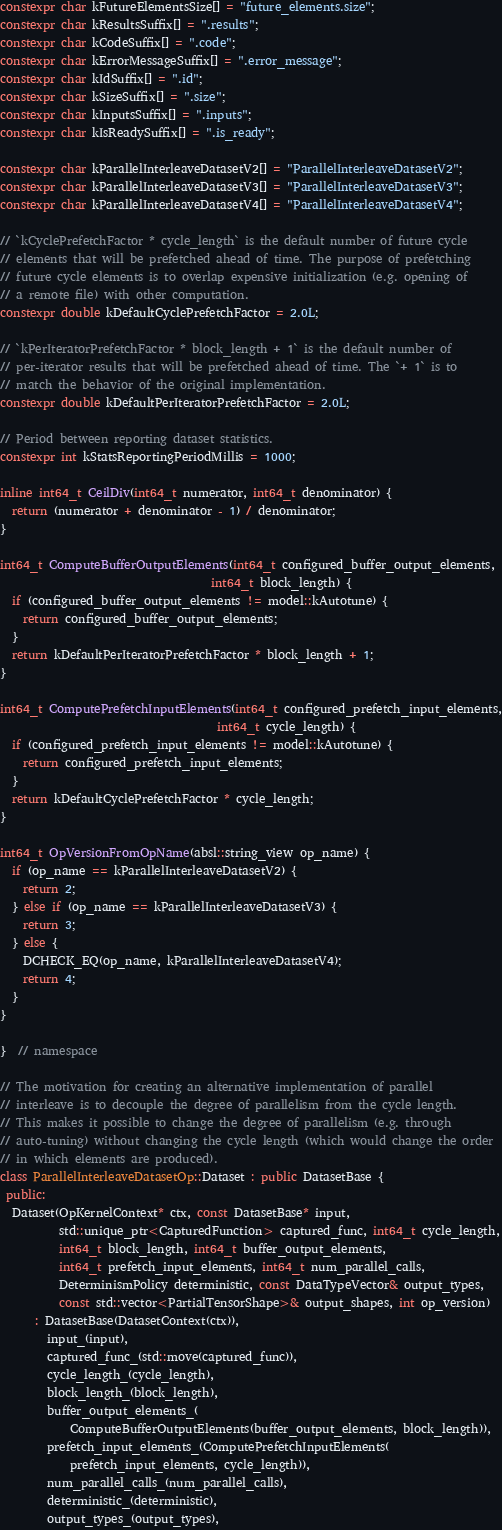<code> <loc_0><loc_0><loc_500><loc_500><_C++_>constexpr char kFutureElementsSize[] = "future_elements.size";
constexpr char kResultsSuffix[] = ".results";
constexpr char kCodeSuffix[] = ".code";
constexpr char kErrorMessageSuffix[] = ".error_message";
constexpr char kIdSuffix[] = ".id";
constexpr char kSizeSuffix[] = ".size";
constexpr char kInputsSuffix[] = ".inputs";
constexpr char kIsReadySuffix[] = ".is_ready";

constexpr char kParallelInterleaveDatasetV2[] = "ParallelInterleaveDatasetV2";
constexpr char kParallelInterleaveDatasetV3[] = "ParallelInterleaveDatasetV3";
constexpr char kParallelInterleaveDatasetV4[] = "ParallelInterleaveDatasetV4";

// `kCyclePrefetchFactor * cycle_length` is the default number of future cycle
// elements that will be prefetched ahead of time. The purpose of prefetching
// future cycle elements is to overlap expensive initialization (e.g. opening of
// a remote file) with other computation.
constexpr double kDefaultCyclePrefetchFactor = 2.0L;

// `kPerIteratorPrefetchFactor * block_length + 1` is the default number of
// per-iterator results that will be prefetched ahead of time. The `+ 1` is to
// match the behavior of the original implementation.
constexpr double kDefaultPerIteratorPrefetchFactor = 2.0L;

// Period between reporting dataset statistics.
constexpr int kStatsReportingPeriodMillis = 1000;

inline int64_t CeilDiv(int64_t numerator, int64_t denominator) {
  return (numerator + denominator - 1) / denominator;
}

int64_t ComputeBufferOutputElements(int64_t configured_buffer_output_elements,
                                    int64_t block_length) {
  if (configured_buffer_output_elements != model::kAutotune) {
    return configured_buffer_output_elements;
  }
  return kDefaultPerIteratorPrefetchFactor * block_length + 1;
}

int64_t ComputePrefetchInputElements(int64_t configured_prefetch_input_elements,
                                     int64_t cycle_length) {
  if (configured_prefetch_input_elements != model::kAutotune) {
    return configured_prefetch_input_elements;
  }
  return kDefaultCyclePrefetchFactor * cycle_length;
}

int64_t OpVersionFromOpName(absl::string_view op_name) {
  if (op_name == kParallelInterleaveDatasetV2) {
    return 2;
  } else if (op_name == kParallelInterleaveDatasetV3) {
    return 3;
  } else {
    DCHECK_EQ(op_name, kParallelInterleaveDatasetV4);
    return 4;
  }
}

}  // namespace

// The motivation for creating an alternative implementation of parallel
// interleave is to decouple the degree of parallelism from the cycle length.
// This makes it possible to change the degree of parallelism (e.g. through
// auto-tuning) without changing the cycle length (which would change the order
// in which elements are produced).
class ParallelInterleaveDatasetOp::Dataset : public DatasetBase {
 public:
  Dataset(OpKernelContext* ctx, const DatasetBase* input,
          std::unique_ptr<CapturedFunction> captured_func, int64_t cycle_length,
          int64_t block_length, int64_t buffer_output_elements,
          int64_t prefetch_input_elements, int64_t num_parallel_calls,
          DeterminismPolicy deterministic, const DataTypeVector& output_types,
          const std::vector<PartialTensorShape>& output_shapes, int op_version)
      : DatasetBase(DatasetContext(ctx)),
        input_(input),
        captured_func_(std::move(captured_func)),
        cycle_length_(cycle_length),
        block_length_(block_length),
        buffer_output_elements_(
            ComputeBufferOutputElements(buffer_output_elements, block_length)),
        prefetch_input_elements_(ComputePrefetchInputElements(
            prefetch_input_elements, cycle_length)),
        num_parallel_calls_(num_parallel_calls),
        deterministic_(deterministic),
        output_types_(output_types),</code> 